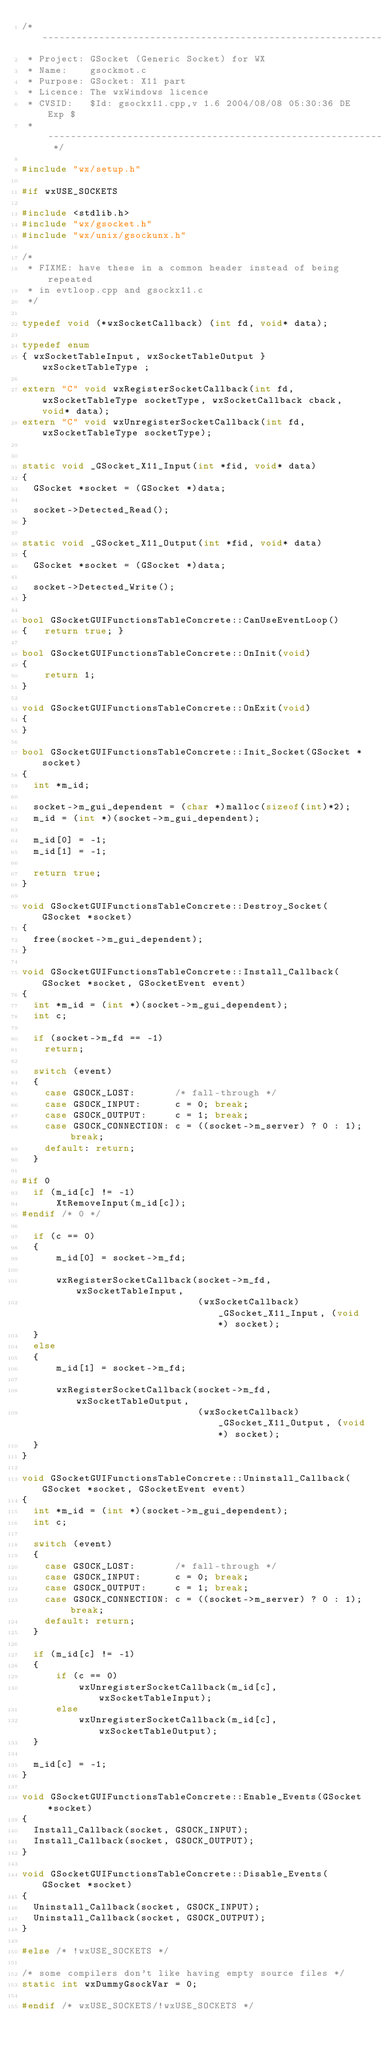Convert code to text. <code><loc_0><loc_0><loc_500><loc_500><_C++_>/* -------------------------------------------------------------------------
 * Project: GSocket (Generic Socket) for WX
 * Name:    gsockmot.c
 * Purpose: GSocket: X11 part
 * Licence: The wxWindows licence
 * CVSID:   $Id: gsockx11.cpp,v 1.6 2004/08/08 05:30:36 DE Exp $
 * ------------------------------------------------------------------------- */

#include "wx/setup.h"

#if wxUSE_SOCKETS

#include <stdlib.h>
#include "wx/gsocket.h"
#include "wx/unix/gsockunx.h"

/*
 * FIXME: have these in a common header instead of being repeated
 * in evtloop.cpp and gsockx11.c
 */

typedef void (*wxSocketCallback) (int fd, void* data);

typedef enum
{ wxSocketTableInput, wxSocketTableOutput } wxSocketTableType ;

extern "C" void wxRegisterSocketCallback(int fd, wxSocketTableType socketType, wxSocketCallback cback, void* data);
extern "C" void wxUnregisterSocketCallback(int fd, wxSocketTableType socketType);


static void _GSocket_X11_Input(int *fid, void* data)
{
  GSocket *socket = (GSocket *)data;
  
  socket->Detected_Read();
}

static void _GSocket_X11_Output(int *fid, void* data)
{
  GSocket *socket = (GSocket *)data;

  socket->Detected_Write();
}

bool GSocketGUIFunctionsTableConcrete::CanUseEventLoop()
{   return true; }

bool GSocketGUIFunctionsTableConcrete::OnInit(void)
{
    return 1;
}

void GSocketGUIFunctionsTableConcrete::OnExit(void)
{
}

bool GSocketGUIFunctionsTableConcrete::Init_Socket(GSocket *socket)
{
  int *m_id;

  socket->m_gui_dependent = (char *)malloc(sizeof(int)*2);
  m_id = (int *)(socket->m_gui_dependent);

  m_id[0] = -1;
  m_id[1] = -1;

  return true;
}

void GSocketGUIFunctionsTableConcrete::Destroy_Socket(GSocket *socket)
{
  free(socket->m_gui_dependent);
}

void GSocketGUIFunctionsTableConcrete::Install_Callback(GSocket *socket, GSocketEvent event)
{
  int *m_id = (int *)(socket->m_gui_dependent);
  int c;

  if (socket->m_fd == -1)
    return;

  switch (event)
  {
    case GSOCK_LOST:       /* fall-through */
    case GSOCK_INPUT:      c = 0; break;
    case GSOCK_OUTPUT:     c = 1; break;
    case GSOCK_CONNECTION: c = ((socket->m_server) ? 0 : 1); break;
    default: return;
  }

#if 0
  if (m_id[c] != -1)
      XtRemoveInput(m_id[c]);
#endif /* 0 */

  if (c == 0)
  {
      m_id[0] = socket->m_fd;

      wxRegisterSocketCallback(socket->m_fd, wxSocketTableInput,
                               (wxSocketCallback) _GSocket_X11_Input, (void*) socket);
  }
  else
  {
      m_id[1] = socket->m_fd;

      wxRegisterSocketCallback(socket->m_fd, wxSocketTableOutput,
                               (wxSocketCallback) _GSocket_X11_Output, (void*) socket);
  }
}

void GSocketGUIFunctionsTableConcrete::Uninstall_Callback(GSocket *socket, GSocketEvent event)
{
  int *m_id = (int *)(socket->m_gui_dependent);
  int c;

  switch (event)
  {
    case GSOCK_LOST:       /* fall-through */
    case GSOCK_INPUT:      c = 0; break;
    case GSOCK_OUTPUT:     c = 1; break;
    case GSOCK_CONNECTION: c = ((socket->m_server) ? 0 : 1); break;
    default: return;
  }

  if (m_id[c] != -1)
  {
      if (c == 0)
          wxUnregisterSocketCallback(m_id[c], wxSocketTableInput);
      else
          wxUnregisterSocketCallback(m_id[c], wxSocketTableOutput);
  }

  m_id[c] = -1;
}

void GSocketGUIFunctionsTableConcrete::Enable_Events(GSocket *socket)
{
  Install_Callback(socket, GSOCK_INPUT);
  Install_Callback(socket, GSOCK_OUTPUT);
}

void GSocketGUIFunctionsTableConcrete::Disable_Events(GSocket *socket)
{
  Uninstall_Callback(socket, GSOCK_INPUT);
  Uninstall_Callback(socket, GSOCK_OUTPUT);
}

#else /* !wxUSE_SOCKETS */

/* some compilers don't like having empty source files */
static int wxDummyGsockVar = 0;

#endif /* wxUSE_SOCKETS/!wxUSE_SOCKETS */
</code> 